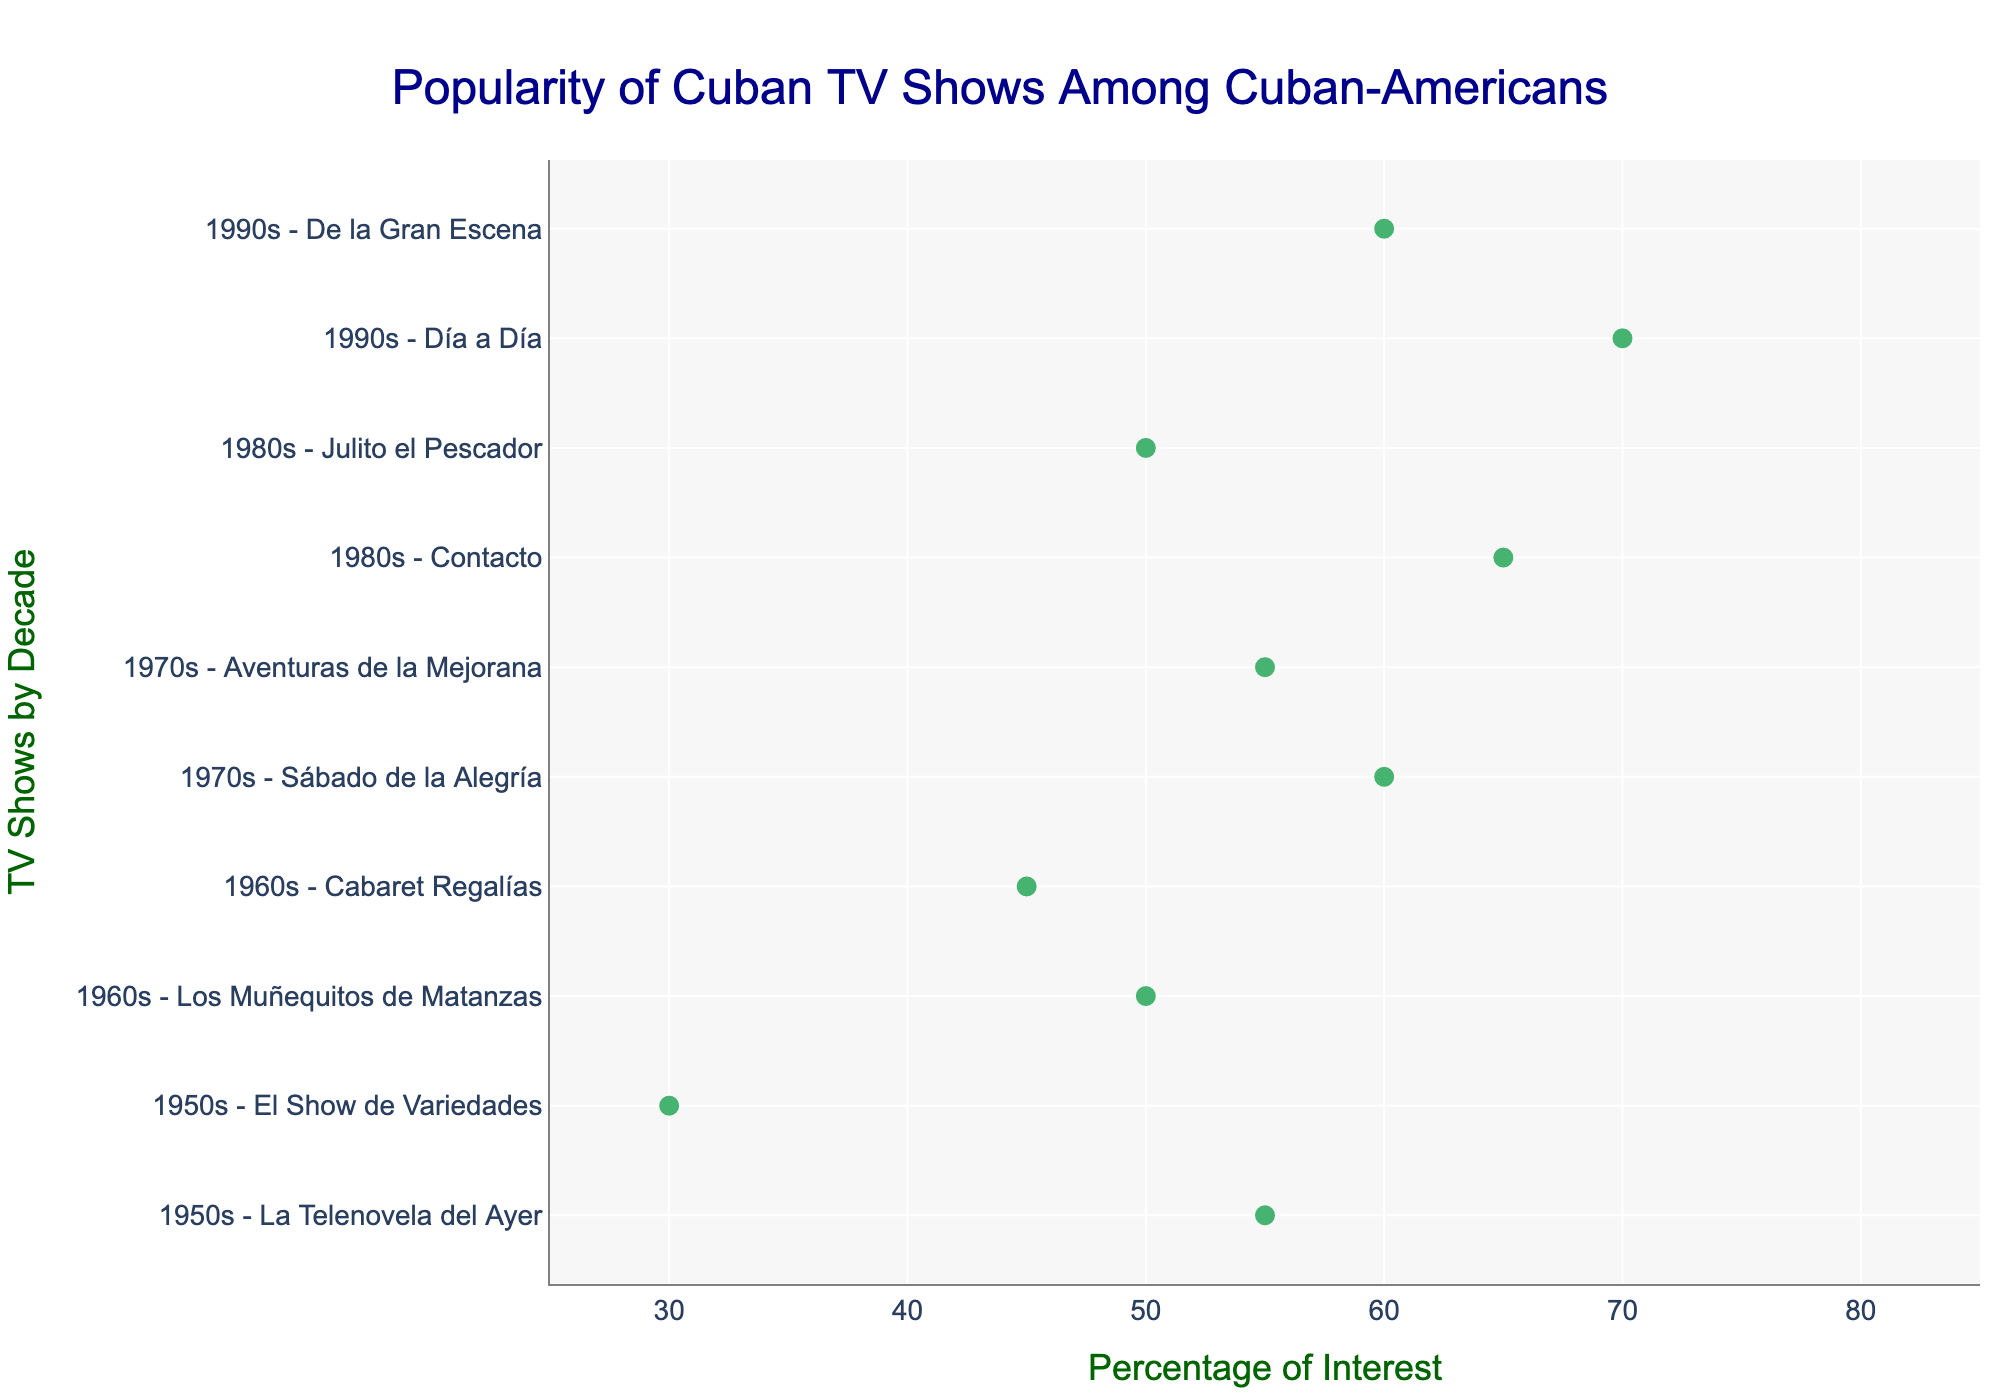What's the title of the plot? The title is located at the top of the plot and it provides an overview of what the plot is about. The title reads "Popularity of Cuban TV Shows Among Cuban-Americans".
Answer: Popularity of Cuban TV Shows Among Cuban-Americans What's the range of the x-axis? The x-axis represents the percentage of interest. According to the plot, the x-axis starts at 25% and ends at 85%.
Answer: 25% to 85% Which decade has the highest percentage of interest for any TV show? By observing the x-axis percentages, "Día a Día" from the 1990s has the highest percentage of interest which ranges from 70% to 80%. The 1990s decade has the highest percentage of interest.
Answer: 1990s What is the average percentage of interest range for "Contacto"? "Contacto" from the 1980s has a range of 65% to 75%. The average percentage is calculated by taking the sum of both percentages and dividing by 2: (65 + 75) / 2 = 70.
Answer: 70% Which TV show has the smallest range of interest percentages? The smallest range is determined by the difference between the high and low percentages for each TV show. "El Show de Variedades" from the 1950s has a range of 45% - 30% = 15%, which is the smallest range.
Answer: El Show de Variedades Which decade has the largest average percentage of interest? To find the largest average percentage, calculate the average for each TV show within a decade, then find the decade with the highest average. If we observe carefully, the 1990s have "Día a Día" (75%) and "De la Gran Escena" (65%), averaging out to 65% + 75% / 2 = 70%. This is higher than other decades.
Answer: 1990s How many TV shows from the 1980s are represented in the plot? By counting the TV shows listed for the 1980s, "Contacto" and "Julito el Pescador" are represented, totaling to 2 TV shows.
Answer: 2 Which TV show from the 1950s has a higher percentage of interest? Comparing the interest percentages for the 1950s, "La Telenovela del Ayer" has a range of 55% to 65%, whereas "El Show de Variedades" has a range of 30% to 45%. Therefore, "La Telenovela del Ayer" has a higher percentage of interest.
Answer: La Telenovela del Ayer What is the total range of interest for TV shows from the 1970s? To find the total range for the 1970s, add the interest ranges for "Sábado de la Alegría" (60% to 70%) and "Aventuras de la Mejorana" (55% to 65%). The total range is (70 - 60) + (65 - 55) = 10 + 10 = 20.
Answer: 20 